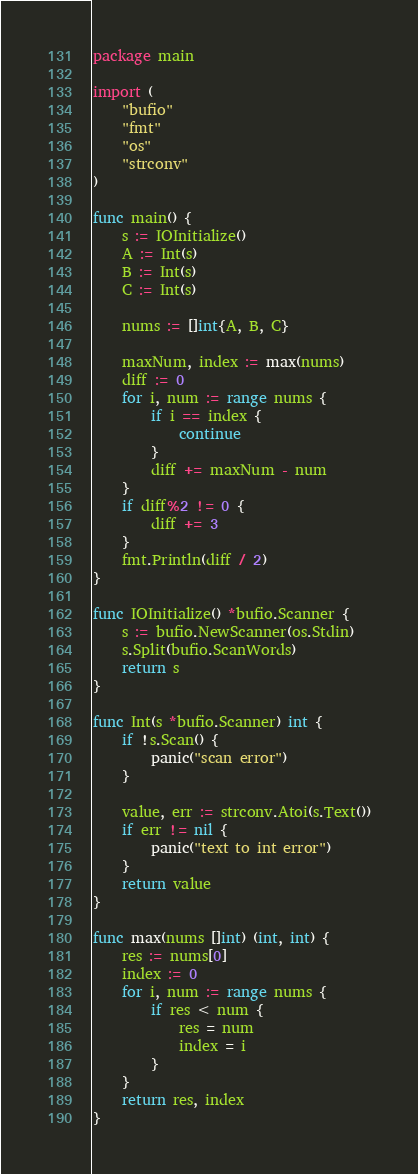Convert code to text. <code><loc_0><loc_0><loc_500><loc_500><_Go_>package main

import (
	"bufio"
	"fmt"
	"os"
	"strconv"
)

func main() {
	s := IOInitialize()
	A := Int(s)
	B := Int(s)
	C := Int(s)

	nums := []int{A, B, C}

	maxNum, index := max(nums)
	diff := 0
	for i, num := range nums {
		if i == index {
			continue
		}
		diff += maxNum - num
	}
	if diff%2 != 0 {
		diff += 3
	}
	fmt.Println(diff / 2)
}

func IOInitialize() *bufio.Scanner {
	s := bufio.NewScanner(os.Stdin)
	s.Split(bufio.ScanWords)
	return s
}

func Int(s *bufio.Scanner) int {
	if !s.Scan() {
		panic("scan error")
	}

	value, err := strconv.Atoi(s.Text())
	if err != nil {
		panic("text to int error")
	}
	return value
}

func max(nums []int) (int, int) {
	res := nums[0]
	index := 0
	for i, num := range nums {
		if res < num {
			res = num
			index = i
		}
	}
	return res, index
}</code> 